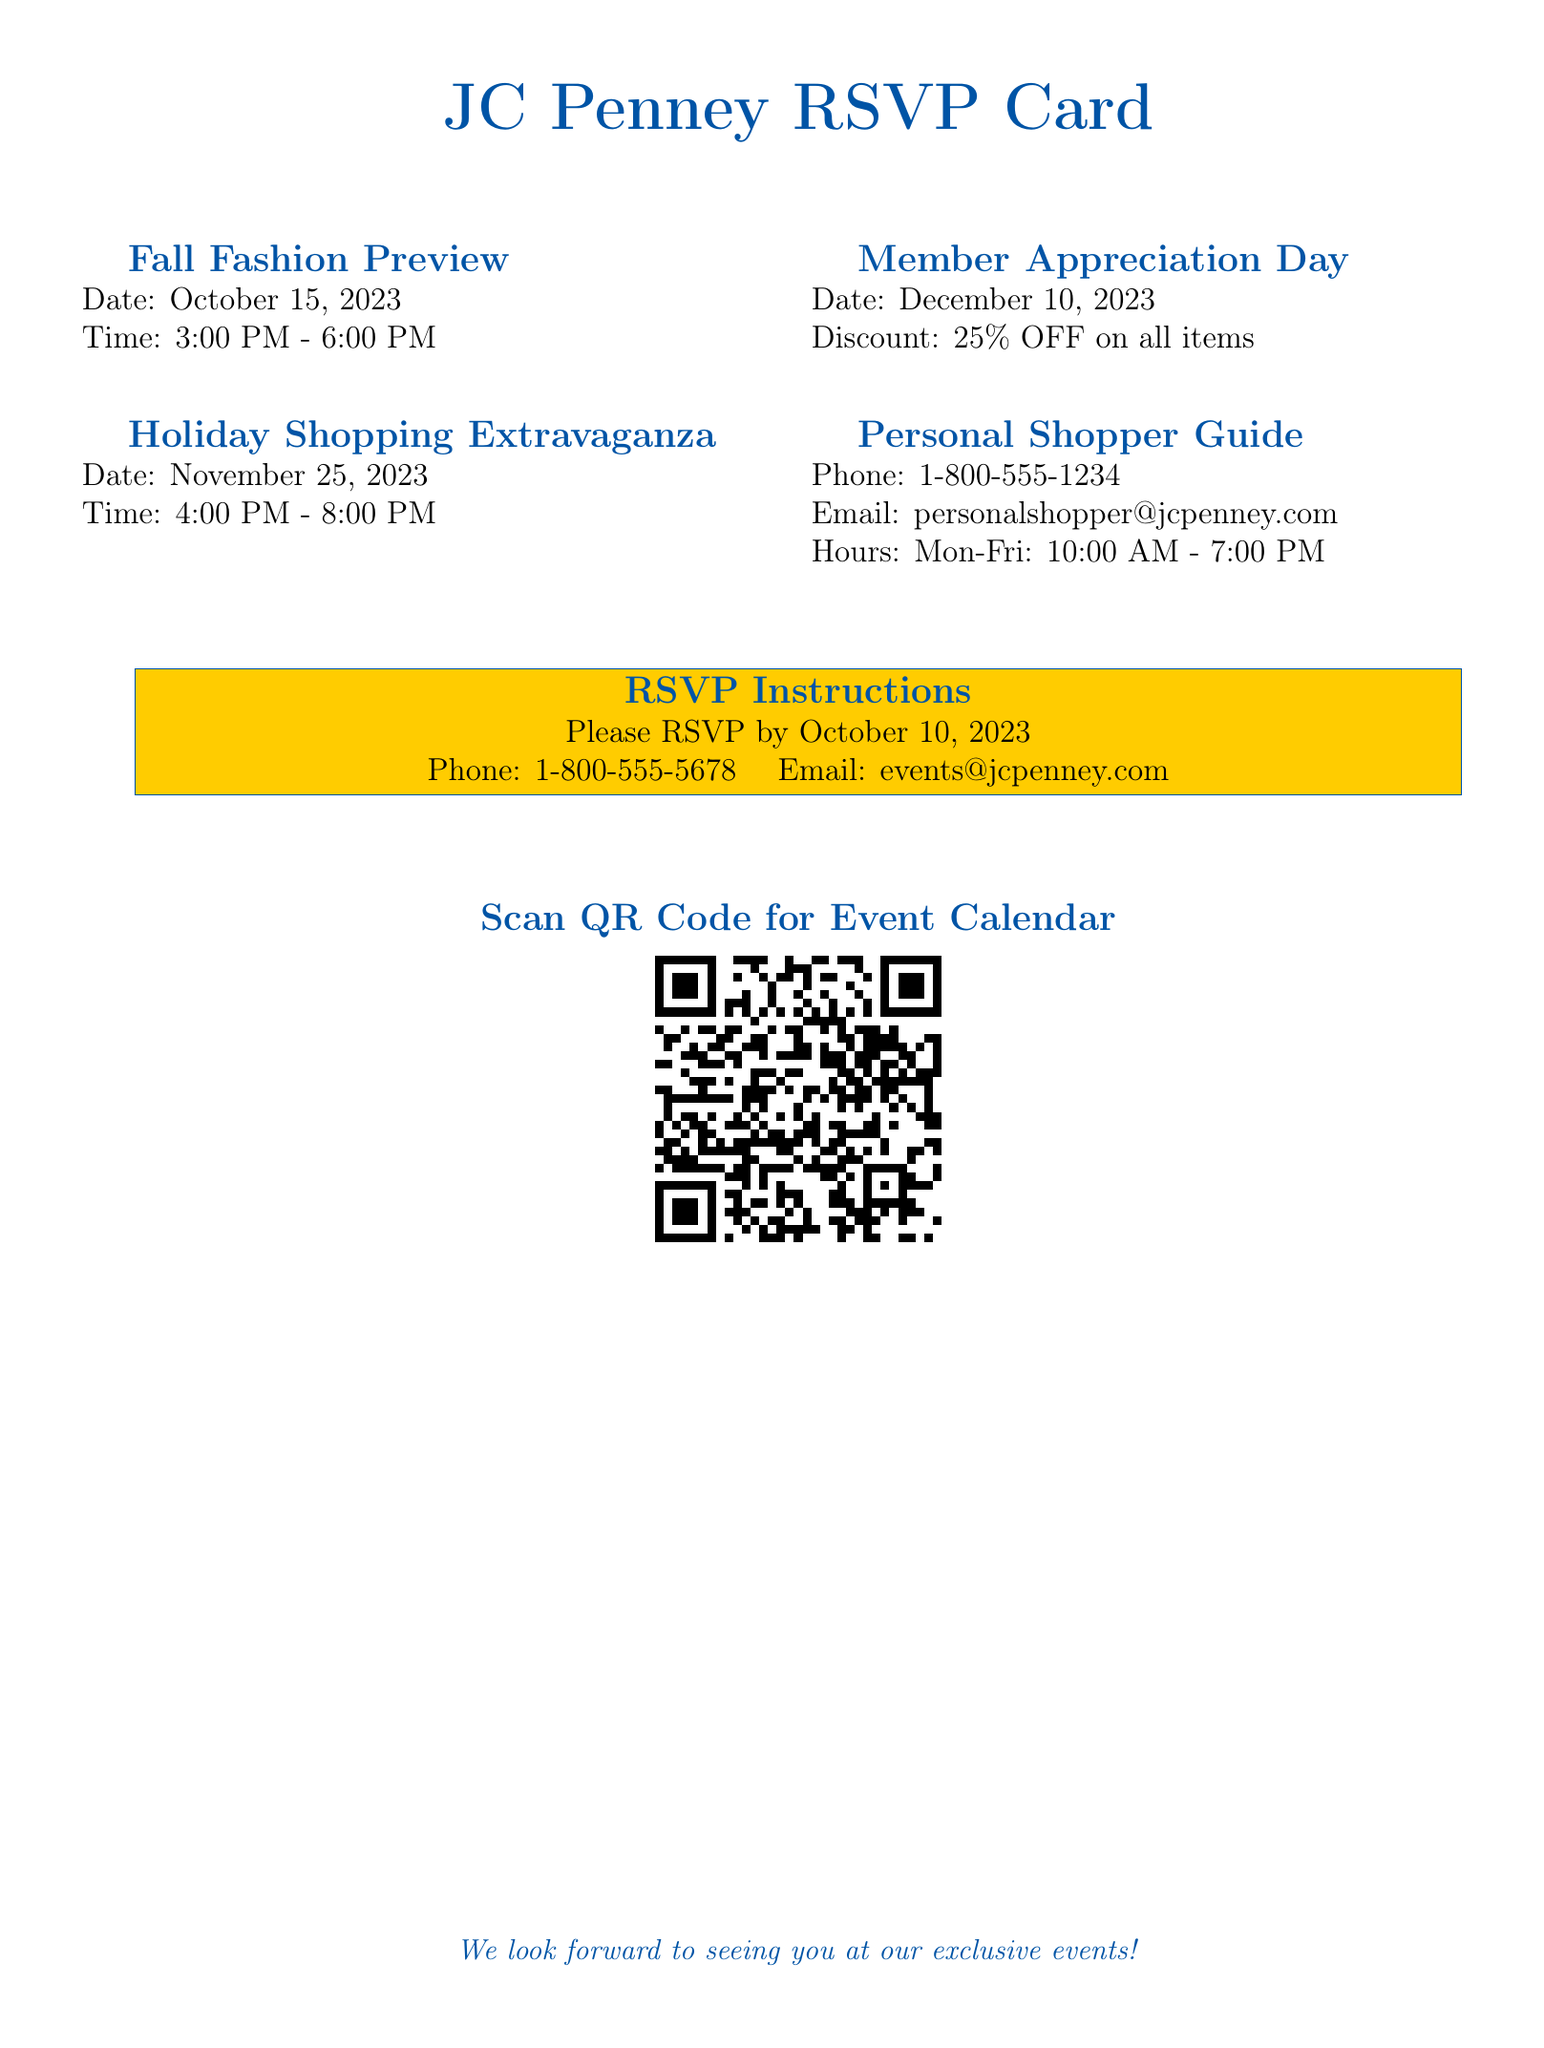What is the date of the Fall Fashion Preview? The date for the Fall Fashion Preview event can be found in the document under the event title.
Answer: October 15, 2023 What time does the Holiday Shopping Extravaganza start? The starting time of the Holiday Shopping Extravaganza is listed in the document.
Answer: 4:00 PM How much discount is offered on Member Appreciation Day? The discount for Member Appreciation Day is specified in the document.
Answer: 25% OFF What is the phone number for the Personal Shopper Guide? The phone number is provided in the section about the Personal Shopper Guide in the document.
Answer: 1-800-555-1234 When is the RSVP deadline? The RSVP deadline is stated clearly in the RSVP Instructions section of the document.
Answer: October 10, 2023 What email address is provided for event RSVPs? The email address for RSVPs is mentioned in the RSVP Instructions section.
Answer: events@jcpenney.com What is the event date for the Holiday Shopping Extravaganza? The date of the Holiday Shopping Extravaganza is listed under the event title in the document.
Answer: November 25, 2023 What should you do to RSVP for the events? The action required to RSVP is outlined in the RSVP Instructions section of the document.
Answer: Call or email What color is the border of the RSVP card? The color of the RSVP card's border can be identified from the styling mentioned in the document.
Answer: jcpblue and jcpgold 